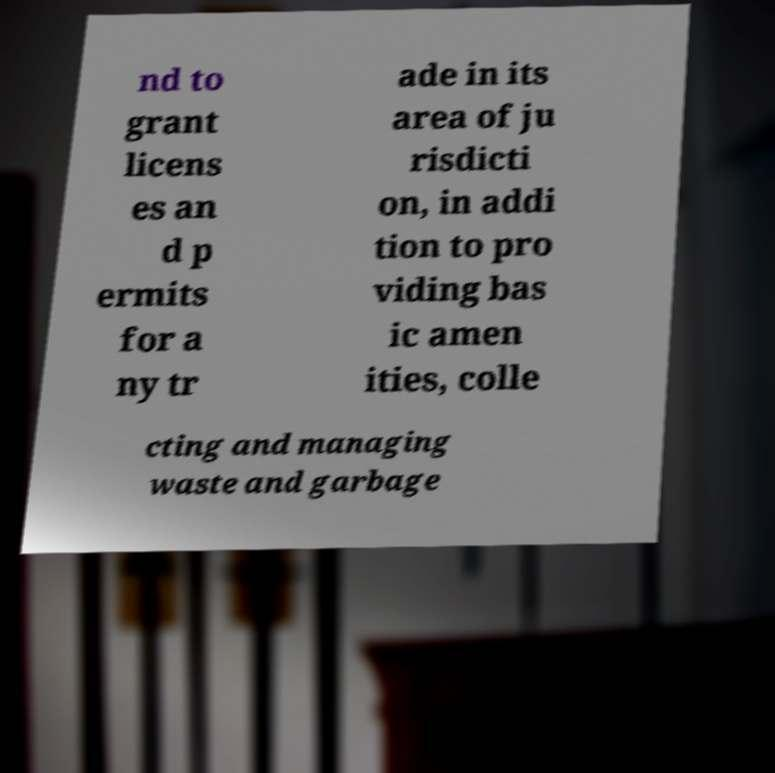For documentation purposes, I need the text within this image transcribed. Could you provide that? nd to grant licens es an d p ermits for a ny tr ade in its area of ju risdicti on, in addi tion to pro viding bas ic amen ities, colle cting and managing waste and garbage 